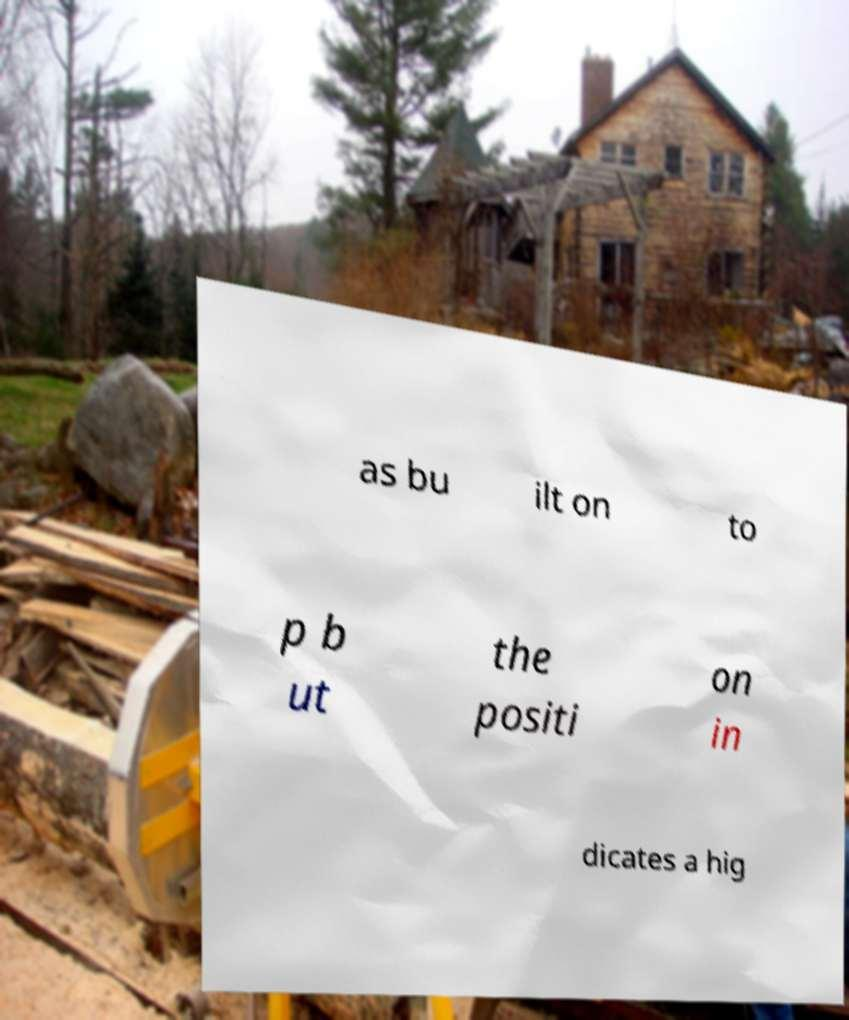Can you read and provide the text displayed in the image?This photo seems to have some interesting text. Can you extract and type it out for me? as bu ilt on to p b ut the positi on in dicates a hig 